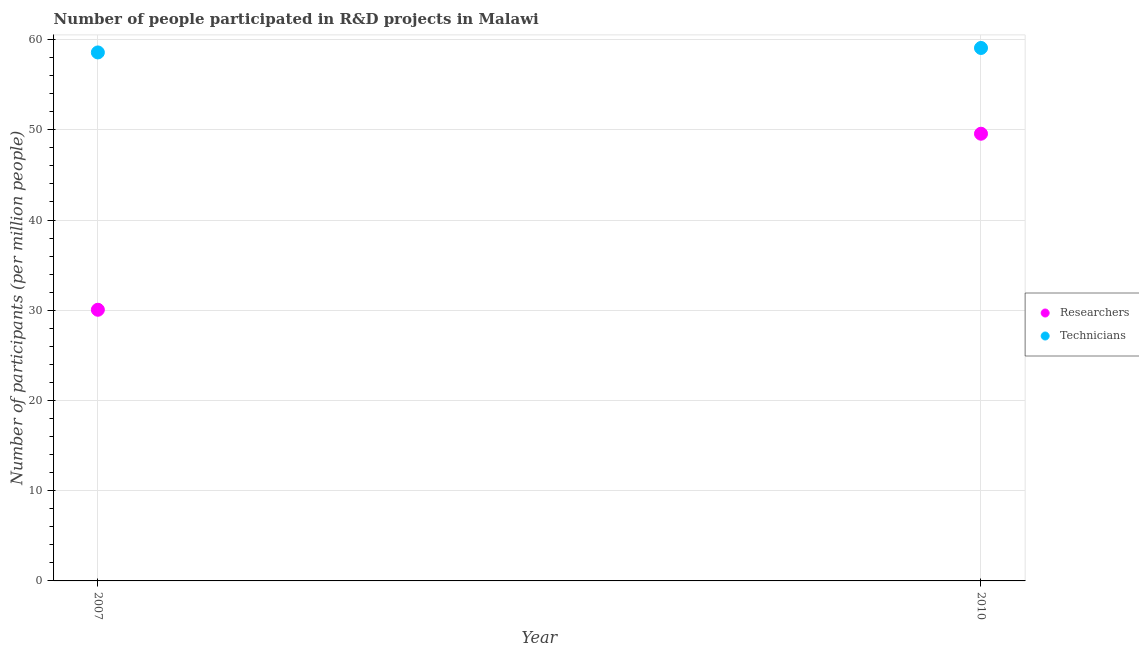How many different coloured dotlines are there?
Your answer should be compact. 2. What is the number of researchers in 2010?
Your answer should be compact. 49.57. Across all years, what is the maximum number of researchers?
Provide a short and direct response. 49.57. Across all years, what is the minimum number of technicians?
Provide a short and direct response. 58.58. In which year was the number of researchers maximum?
Give a very brief answer. 2010. In which year was the number of technicians minimum?
Give a very brief answer. 2007. What is the total number of researchers in the graph?
Provide a succinct answer. 79.62. What is the difference between the number of technicians in 2007 and that in 2010?
Your response must be concise. -0.5. What is the difference between the number of technicians in 2007 and the number of researchers in 2010?
Provide a short and direct response. 9.01. What is the average number of technicians per year?
Offer a very short reply. 58.83. In the year 2007, what is the difference between the number of researchers and number of technicians?
Ensure brevity in your answer.  -28.52. What is the ratio of the number of researchers in 2007 to that in 2010?
Ensure brevity in your answer.  0.61. Is the number of researchers in 2007 less than that in 2010?
Give a very brief answer. Yes. Does the number of researchers monotonically increase over the years?
Your response must be concise. Yes. Is the number of technicians strictly less than the number of researchers over the years?
Offer a very short reply. No. How many dotlines are there?
Give a very brief answer. 2. How many years are there in the graph?
Provide a short and direct response. 2. How many legend labels are there?
Make the answer very short. 2. What is the title of the graph?
Offer a very short reply. Number of people participated in R&D projects in Malawi. Does "Time to import" appear as one of the legend labels in the graph?
Offer a terse response. No. What is the label or title of the Y-axis?
Offer a terse response. Number of participants (per million people). What is the Number of participants (per million people) of Researchers in 2007?
Provide a short and direct response. 30.06. What is the Number of participants (per million people) in Technicians in 2007?
Offer a very short reply. 58.58. What is the Number of participants (per million people) in Researchers in 2010?
Provide a succinct answer. 49.57. What is the Number of participants (per million people) in Technicians in 2010?
Ensure brevity in your answer.  59.07. Across all years, what is the maximum Number of participants (per million people) of Researchers?
Offer a terse response. 49.57. Across all years, what is the maximum Number of participants (per million people) in Technicians?
Make the answer very short. 59.07. Across all years, what is the minimum Number of participants (per million people) in Researchers?
Make the answer very short. 30.06. Across all years, what is the minimum Number of participants (per million people) in Technicians?
Offer a very short reply. 58.58. What is the total Number of participants (per million people) of Researchers in the graph?
Make the answer very short. 79.62. What is the total Number of participants (per million people) in Technicians in the graph?
Give a very brief answer. 117.65. What is the difference between the Number of participants (per million people) of Researchers in 2007 and that in 2010?
Keep it short and to the point. -19.51. What is the difference between the Number of participants (per million people) in Technicians in 2007 and that in 2010?
Offer a terse response. -0.5. What is the difference between the Number of participants (per million people) of Researchers in 2007 and the Number of participants (per million people) of Technicians in 2010?
Your answer should be very brief. -29.02. What is the average Number of participants (per million people) in Researchers per year?
Provide a short and direct response. 39.81. What is the average Number of participants (per million people) of Technicians per year?
Your response must be concise. 58.83. In the year 2007, what is the difference between the Number of participants (per million people) in Researchers and Number of participants (per million people) in Technicians?
Ensure brevity in your answer.  -28.52. In the year 2010, what is the difference between the Number of participants (per million people) of Researchers and Number of participants (per million people) of Technicians?
Your answer should be very brief. -9.51. What is the ratio of the Number of participants (per million people) of Researchers in 2007 to that in 2010?
Make the answer very short. 0.61. What is the difference between the highest and the second highest Number of participants (per million people) of Researchers?
Your answer should be compact. 19.51. What is the difference between the highest and the second highest Number of participants (per million people) of Technicians?
Provide a short and direct response. 0.5. What is the difference between the highest and the lowest Number of participants (per million people) in Researchers?
Your answer should be very brief. 19.51. What is the difference between the highest and the lowest Number of participants (per million people) of Technicians?
Your response must be concise. 0.5. 